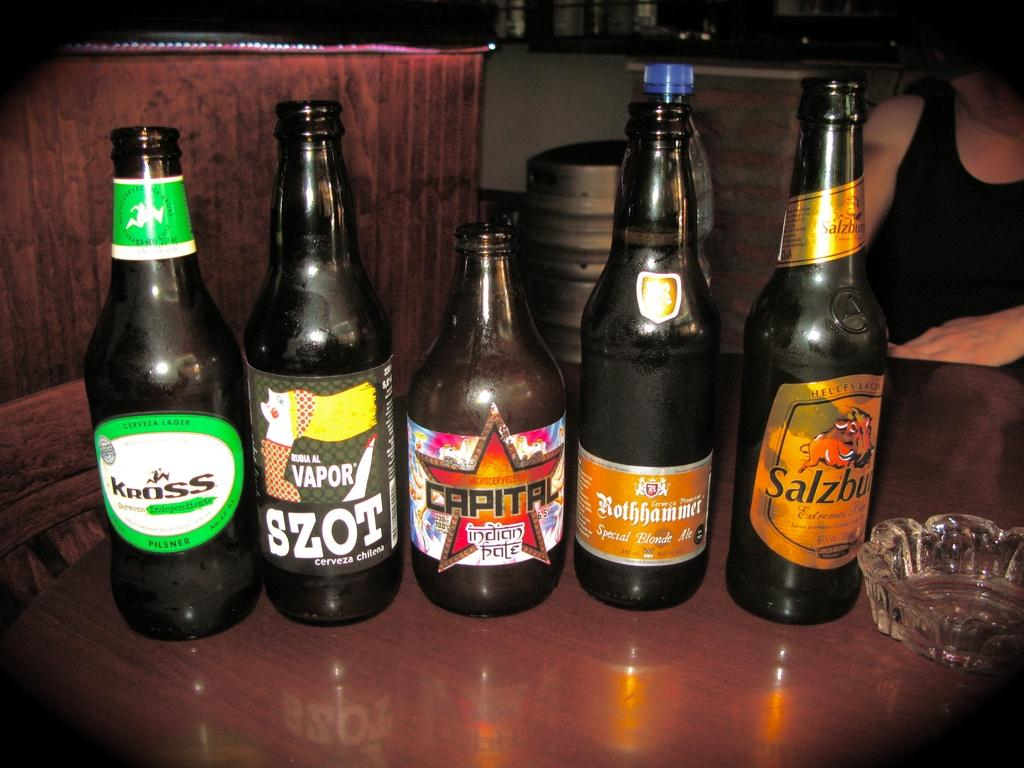Provide a one-sentence caption for the provided image. 5 bottles of beer next to each other with Capital indian pale in the middle. 